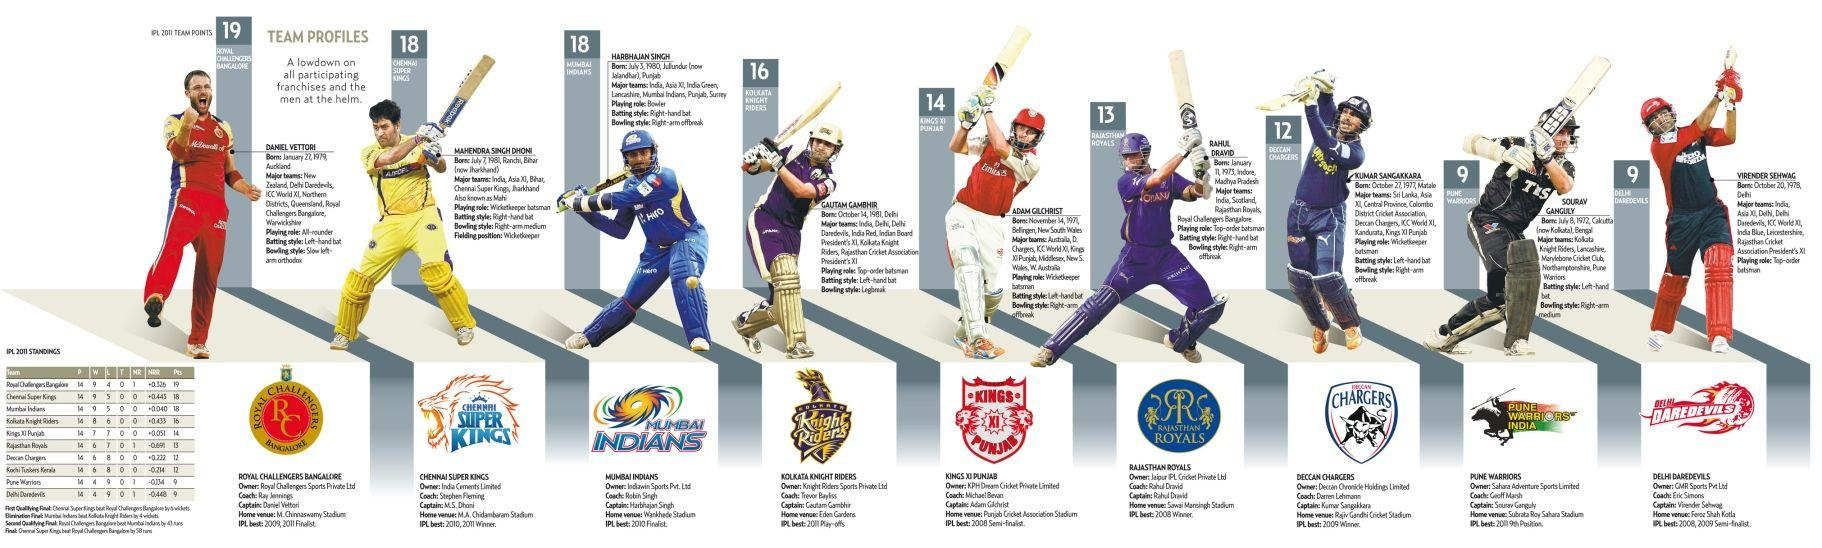List a handful of essential elements in this visual. As of my knowledge cutoff date of September 2021, the win percentage of Royal Challengers Bangalore was 64.2857%. Kumar Sangakkara is the captain of the Deccan Chargers cricket team. Daniel Vettori played the role of an all-rounder in the game. Chennai Super Kings won the second place in IPL 2011. The home ground of Kolkata Knight Riders is Eden Gardens, located in the city of Kolkata. 